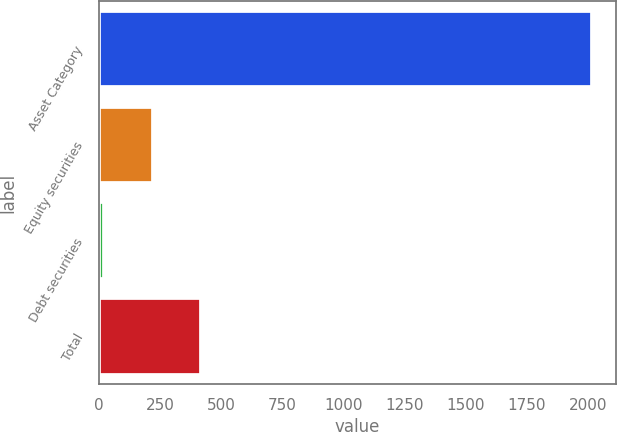Convert chart. <chart><loc_0><loc_0><loc_500><loc_500><bar_chart><fcel>Asset Category<fcel>Equity securities<fcel>Debt securities<fcel>Total<nl><fcel>2016<fcel>219.05<fcel>19.39<fcel>418.71<nl></chart> 